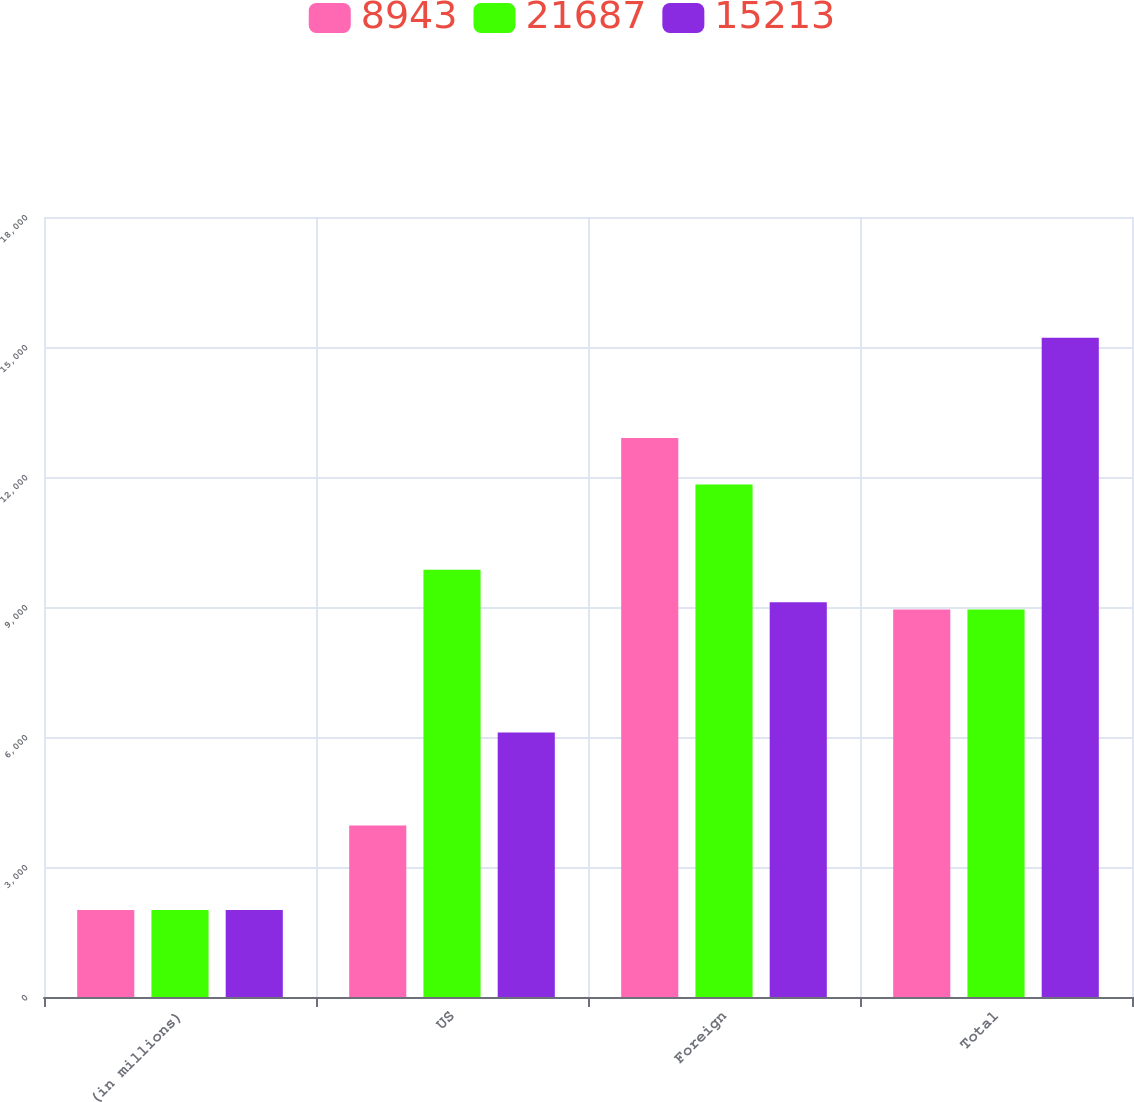Convert chart. <chart><loc_0><loc_0><loc_500><loc_500><stacked_bar_chart><ecel><fcel>(in millions)<fcel>US<fcel>Foreign<fcel>Total<nl><fcel>8943<fcel>2007<fcel>3957<fcel>12900<fcel>8943<nl><fcel>21687<fcel>2006<fcel>9862<fcel>11825<fcel>8943<nl><fcel>15213<fcel>2005<fcel>6103<fcel>9110<fcel>15213<nl></chart> 